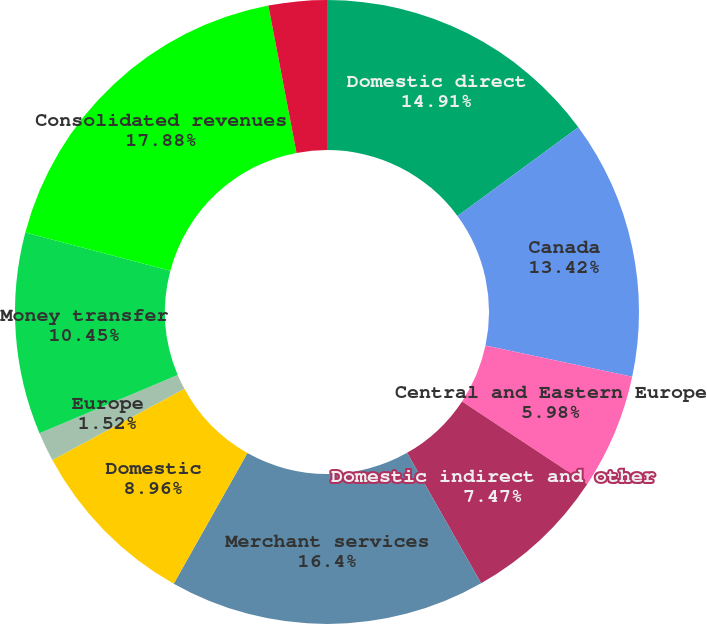<chart> <loc_0><loc_0><loc_500><loc_500><pie_chart><fcel>Domestic direct<fcel>Canada<fcel>Central and Eastern Europe<fcel>Domestic indirect and other<fcel>Merchant services<fcel>Domestic<fcel>Europe<fcel>Money transfer<fcel>Consolidated revenues<fcel>Corporate<nl><fcel>14.91%<fcel>13.42%<fcel>5.98%<fcel>7.47%<fcel>16.4%<fcel>8.96%<fcel>1.52%<fcel>10.45%<fcel>17.89%<fcel>3.01%<nl></chart> 